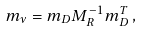<formula> <loc_0><loc_0><loc_500><loc_500>m _ { \nu } = m _ { D } M _ { R } ^ { - 1 } m _ { D } ^ { T } \, ,</formula> 